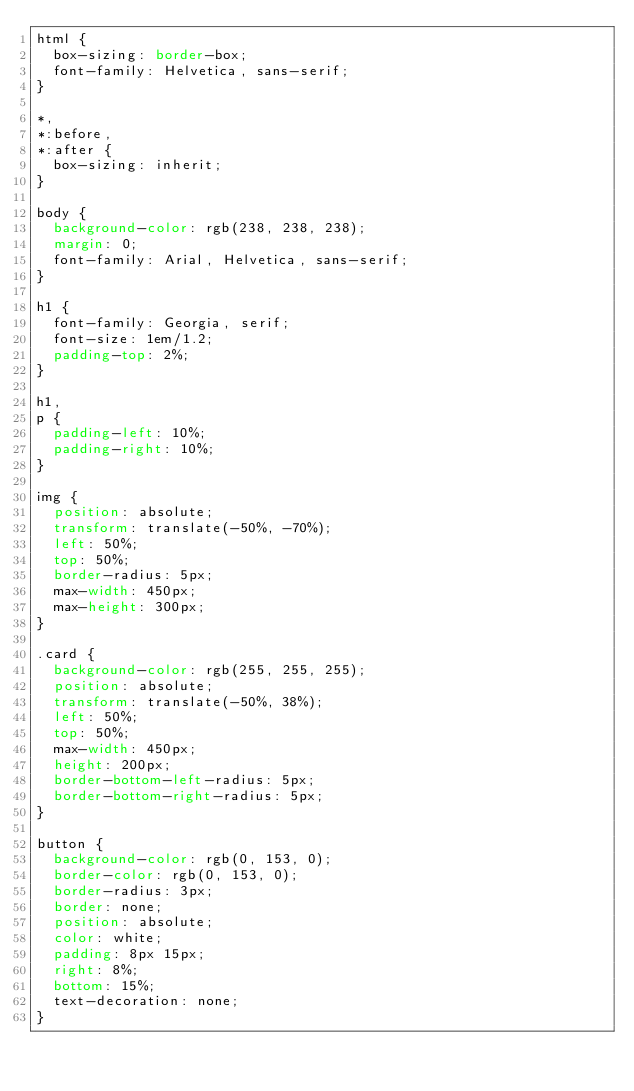Convert code to text. <code><loc_0><loc_0><loc_500><loc_500><_CSS_>html {
  box-sizing: border-box;
  font-family: Helvetica, sans-serif;
}

*,
*:before,
*:after {
  box-sizing: inherit;
}

body {
  background-color: rgb(238, 238, 238);
  margin: 0;
  font-family: Arial, Helvetica, sans-serif;
}

h1 {
  font-family: Georgia, serif;
  font-size: 1em/1.2;
  padding-top: 2%;
}

h1,
p {
  padding-left: 10%;
  padding-right: 10%;
}

img {
  position: absolute;
  transform: translate(-50%, -70%);
  left: 50%;
  top: 50%;
  border-radius: 5px;
  max-width: 450px;
  max-height: 300px;
}

.card {
  background-color: rgb(255, 255, 255);
  position: absolute;
  transform: translate(-50%, 38%);
  left: 50%;
  top: 50%;
  max-width: 450px;
  height: 200px;
  border-bottom-left-radius: 5px;
  border-bottom-right-radius: 5px;
}

button {
  background-color: rgb(0, 153, 0);
  border-color: rgb(0, 153, 0);
  border-radius: 3px;
  border: none;
  position: absolute;
  color: white;
  padding: 8px 15px;
  right: 8%;
  bottom: 15%;
  text-decoration: none;
}
</code> 